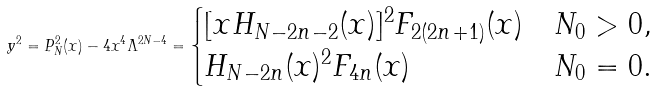<formula> <loc_0><loc_0><loc_500><loc_500>y ^ { 2 } = P _ { N } ^ { 2 } ( x ) - 4 x ^ { 4 } \Lambda ^ { 2 N - 4 } = \begin{cases} [ x H _ { N - 2 n - 2 } ( x ) ] ^ { 2 } F _ { 2 ( 2 n + 1 ) } ( x ) & N _ { 0 } > 0 , \\ H _ { N - 2 n } ( x ) ^ { 2 } F _ { 4 n } ( x ) & N _ { 0 } = 0 . \end{cases}</formula> 